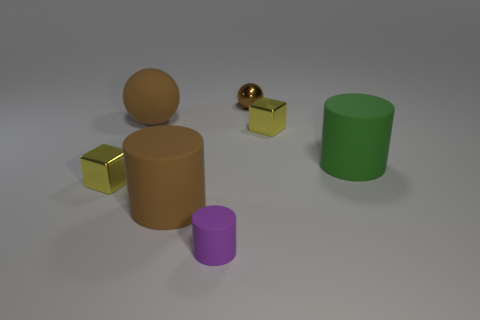Add 2 small matte things. How many objects exist? 9 Subtract all spheres. How many objects are left? 5 Add 1 large yellow cylinders. How many large yellow cylinders exist? 1 Subtract 0 red balls. How many objects are left? 7 Subtract all large red rubber blocks. Subtract all rubber balls. How many objects are left? 6 Add 2 big brown things. How many big brown things are left? 4 